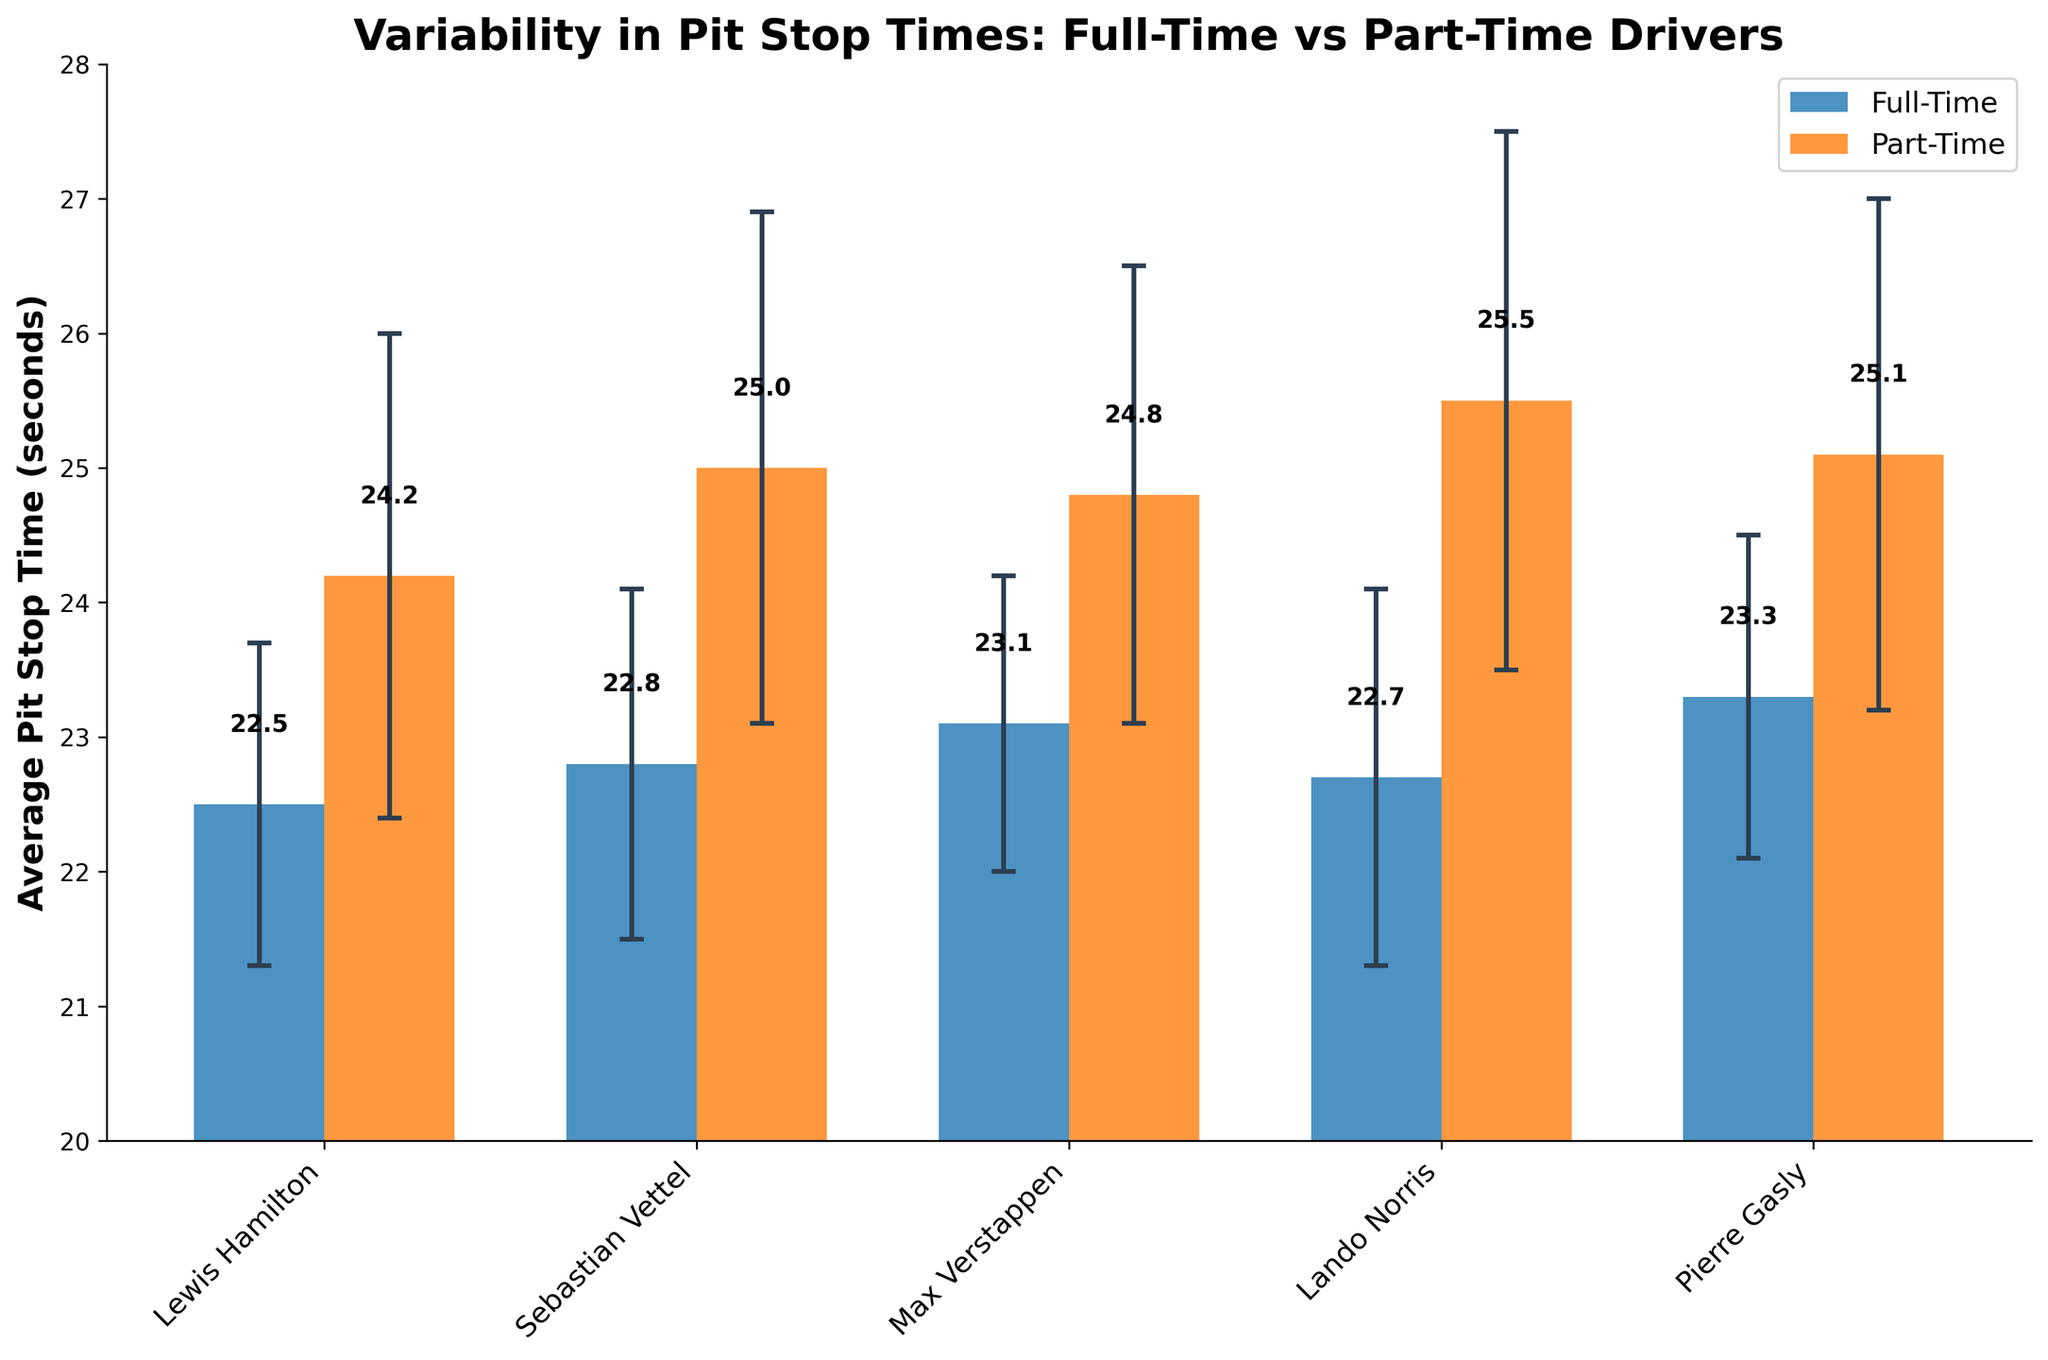What's the title of the figure? The title of the figure is displayed at the top of the chart in bold, providing an overview of the visualized data.
Answer: Variability in Pit Stop Times: Full-Time vs Part-Time Drivers What is the y-axis label? The label of the y-axis is provided to indicate what the values represent, which is important to understand the metric shown.
Answer: Average Pit Stop Time (seconds) Which driver has the lowest average pit stop time? By examining the height of the bars, we can see that the bar representing the driver with the smallest average pit stop time is the shortest.
Answer: Lewis Hamilton Which driver has the highest average pit stop time? By identifying the tallest bar on the plot, it corresponds to the driver with the highest average pit stop time.
Answer: Sebastian Buemi What is the range of the y-axis? The range of the y-axis can be observed by checking the minimum and maximum values on the y-scale.
Answer: 20 to 28 Which category of drivers generally has higher average pit stop times? By comparing the general heights of the two groups of bars (representing full-time and part-time drivers), we can determine which group usually has higher values.
Answer: Part-Time Is there a significant overlap in pit stop times between the two categories of drivers? Observing the error bars for both categories can help to see if the ranges (average ± std dev) overlap significantly between the two categories.
Answer: Yes Which full-time driver has the most variable pit stop time? By examining the lengths of the error bars for the full-time drivers, the driver with the largest error bar has the most variation.
Answer: Lando Norris What is the approximate average pit stop time for full-time drivers? Summing the average pit stop times of all full-time drivers and then dividing by the number of full-time drivers provides the average.
Answer: (22.5 + 22.8 + 23.1 + 22.7 + 23.3) / 5 = 22.88 What is the difference in average pit stop time between the fastest full-time driver and the fastest part-time driver? Subtract the lowest average pit stop time among part-time drivers from the lowest average pit stop time among full-time drivers.
Answer: 24.2 - 22.5 = 1.7 seconds 